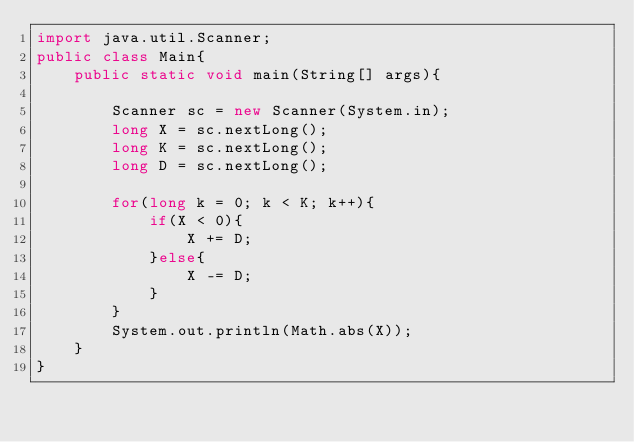<code> <loc_0><loc_0><loc_500><loc_500><_Java_>import java.util.Scanner;
public class Main{
	public static void main(String[] args){
		
      	Scanner sc = new Scanner(System.in);
      	long X = sc.nextLong();
     	long K = sc.nextLong();
		long D = sc.nextLong();
      	
      	for(long k = 0; k < K; k++){
        	if(X < 0){
            	X += D;
            }else{
            	X -= D;
            }
        }
      	System.out.println(Math.abs(X));
	}
}</code> 